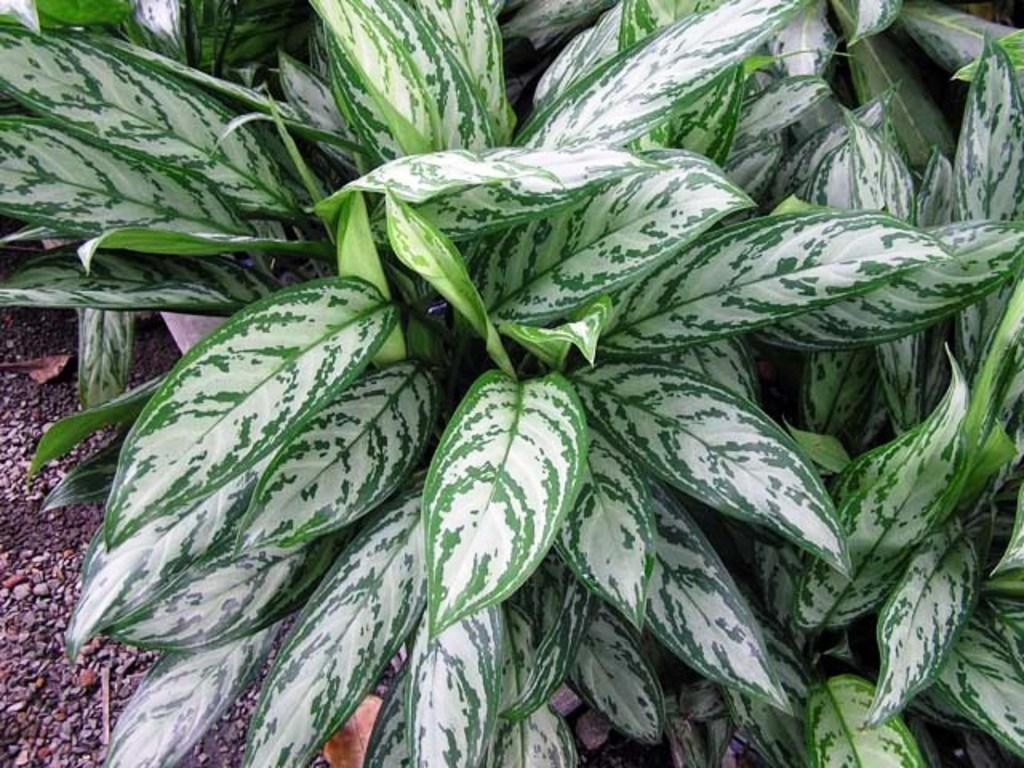What type of plant is visible in the image? The image contains leaves of a plant, but it does not specify the type of plant. Can you describe the appearance of the leaves in the image? The leaves appear to be green and may have veins or other distinguishing features. Are there any other elements present in the image besides the plant leaves? The provided facts do not mention any other elements in the image. What date is circled on the calendar in the image? There is no calendar present in the image, so it is not possible to answer that question. 